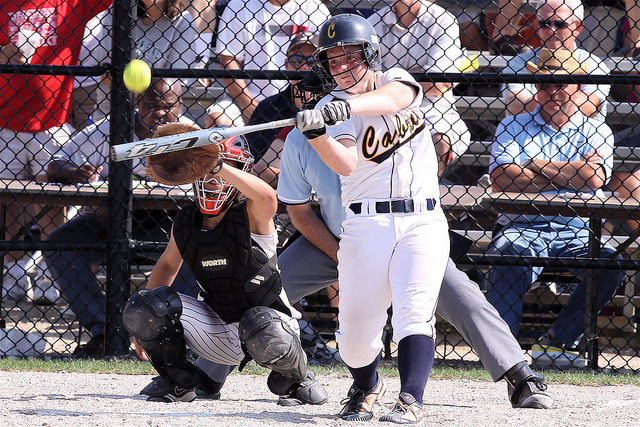What is the main activity happening in the image? The main activity depicted in the image is a softball game. A batter is in the midst of swinging the bat at an incoming pitch, while a catcher is ready behind her, and an umpire is observing the play attentively. 